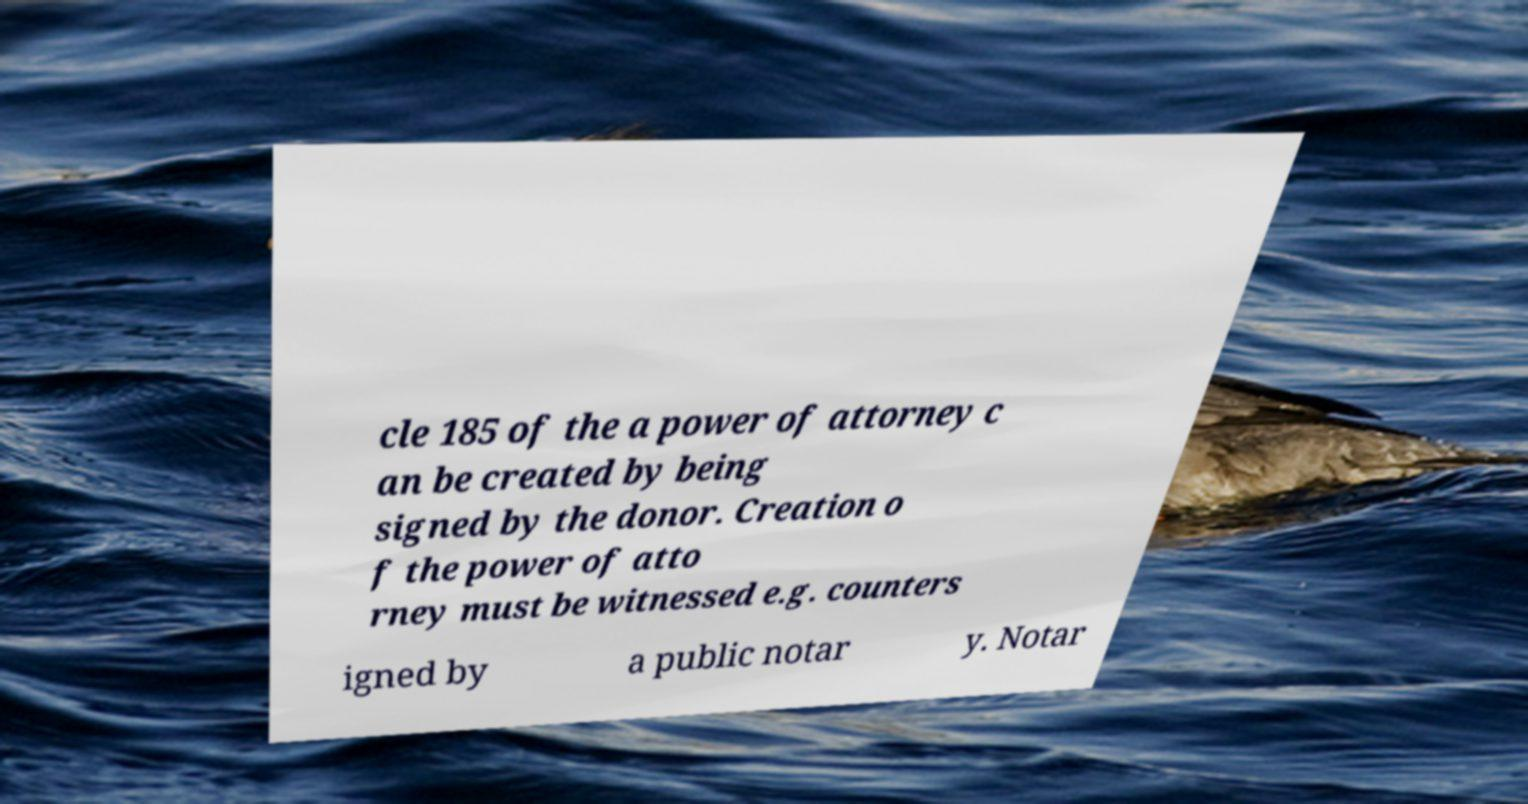Can you accurately transcribe the text from the provided image for me? cle 185 of the a power of attorney c an be created by being signed by the donor. Creation o f the power of atto rney must be witnessed e.g. counters igned by a public notar y. Notar 